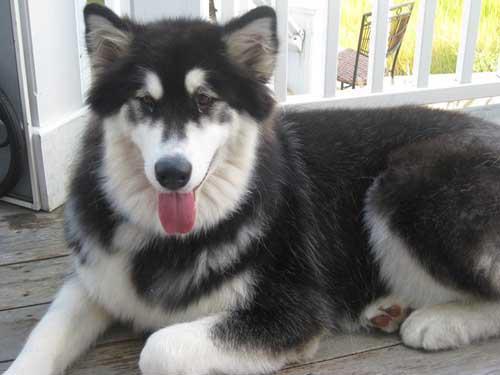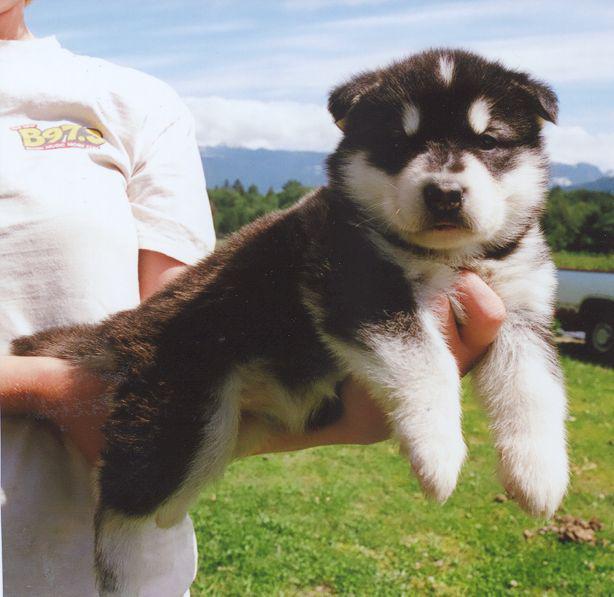The first image is the image on the left, the second image is the image on the right. For the images displayed, is the sentence "There are an equal number of dogs in each image." factually correct? Answer yes or no. Yes. The first image is the image on the left, the second image is the image on the right. Examine the images to the left and right. Is the description "The left and right image contains the same number of dogs." accurate? Answer yes or no. Yes. 